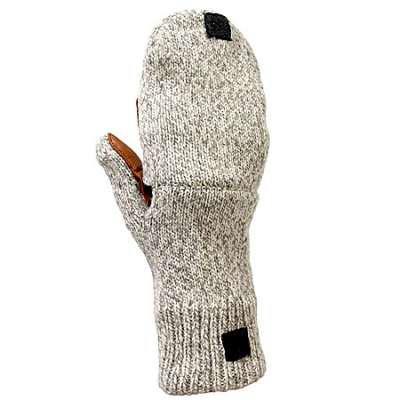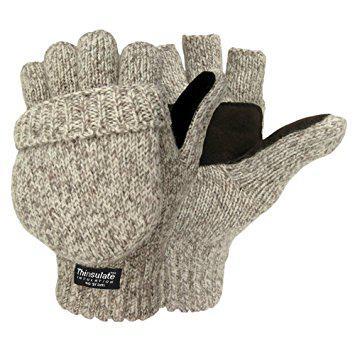The first image is the image on the left, the second image is the image on the right. For the images displayed, is the sentence "A fingerless glove in a taupe color with ribbed detailing in the wrist section is modeled in one image by a black hand mannequin." factually correct? Answer yes or no. No. The first image is the image on the left, the second image is the image on the right. Evaluate the accuracy of this statement regarding the images: "a mannequin's hand is wearing a glove.". Is it true? Answer yes or no. No. 